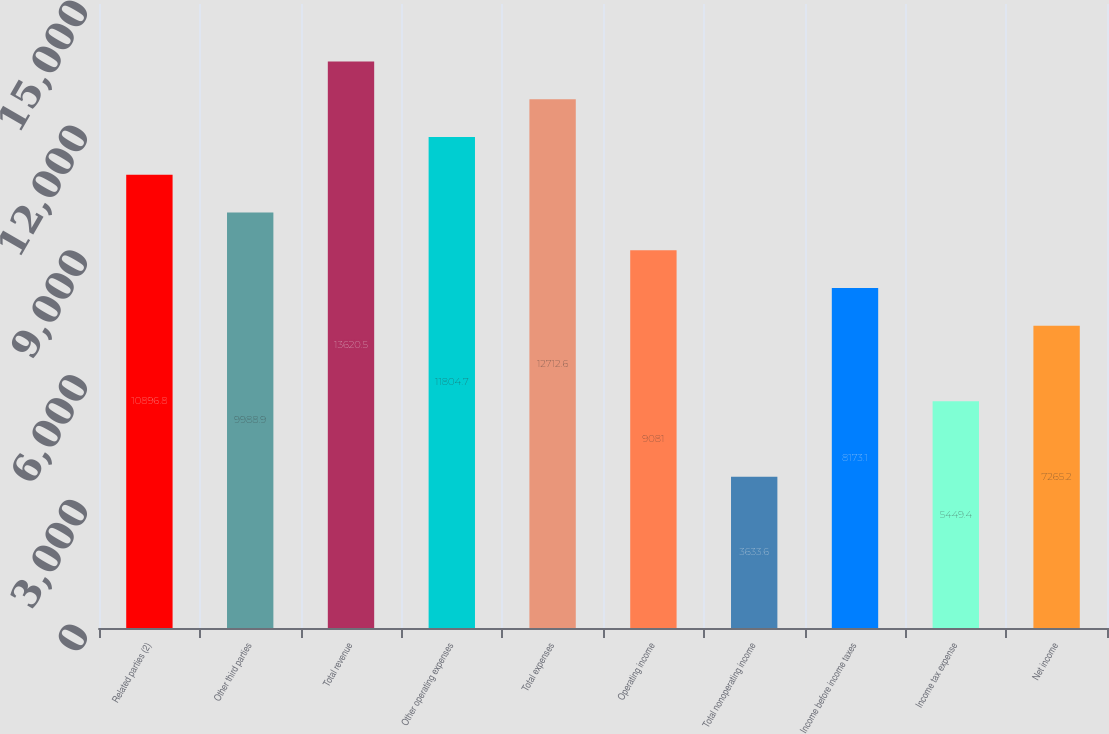Convert chart to OTSL. <chart><loc_0><loc_0><loc_500><loc_500><bar_chart><fcel>Related parties (2)<fcel>Other third parties<fcel>Total revenue<fcel>Other operating expenses<fcel>Total expenses<fcel>Operating income<fcel>Total nonoperating income<fcel>Income before income taxes<fcel>Income tax expense<fcel>Net income<nl><fcel>10896.8<fcel>9988.9<fcel>13620.5<fcel>11804.7<fcel>12712.6<fcel>9081<fcel>3633.6<fcel>8173.1<fcel>5449.4<fcel>7265.2<nl></chart> 